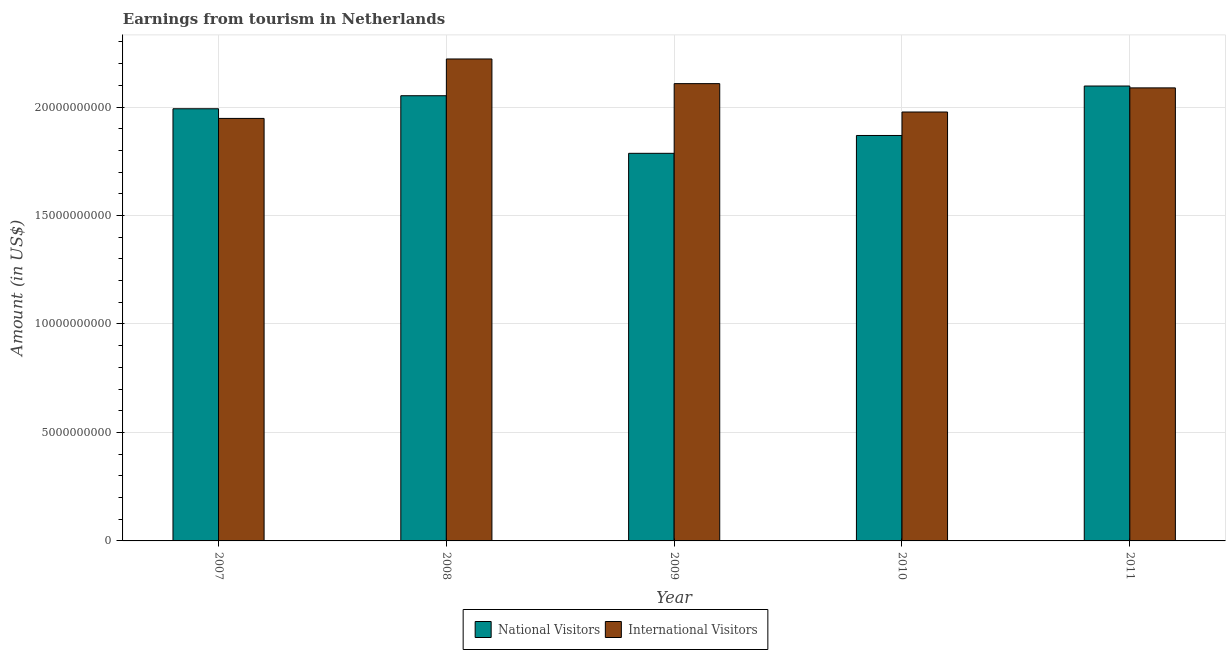How many different coloured bars are there?
Offer a terse response. 2. Are the number of bars on each tick of the X-axis equal?
Provide a short and direct response. Yes. How many bars are there on the 4th tick from the right?
Ensure brevity in your answer.  2. What is the label of the 2nd group of bars from the left?
Keep it short and to the point. 2008. In how many cases, is the number of bars for a given year not equal to the number of legend labels?
Provide a short and direct response. 0. What is the amount earned from national visitors in 2010?
Keep it short and to the point. 1.87e+1. Across all years, what is the maximum amount earned from national visitors?
Your response must be concise. 2.10e+1. Across all years, what is the minimum amount earned from international visitors?
Make the answer very short. 1.95e+1. In which year was the amount earned from international visitors maximum?
Give a very brief answer. 2008. In which year was the amount earned from national visitors minimum?
Keep it short and to the point. 2009. What is the total amount earned from international visitors in the graph?
Your answer should be very brief. 1.03e+11. What is the difference between the amount earned from national visitors in 2007 and that in 2010?
Your response must be concise. 1.23e+09. What is the difference between the amount earned from national visitors in 2009 and the amount earned from international visitors in 2007?
Keep it short and to the point. -2.05e+09. What is the average amount earned from international visitors per year?
Keep it short and to the point. 2.07e+1. In the year 2009, what is the difference between the amount earned from international visitors and amount earned from national visitors?
Provide a short and direct response. 0. What is the ratio of the amount earned from international visitors in 2007 to that in 2011?
Offer a very short reply. 0.93. Is the amount earned from national visitors in 2009 less than that in 2010?
Keep it short and to the point. Yes. Is the difference between the amount earned from national visitors in 2009 and 2011 greater than the difference between the amount earned from international visitors in 2009 and 2011?
Your response must be concise. No. What is the difference between the highest and the second highest amount earned from international visitors?
Provide a succinct answer. 1.14e+09. What is the difference between the highest and the lowest amount earned from international visitors?
Your response must be concise. 2.74e+09. Is the sum of the amount earned from international visitors in 2007 and 2008 greater than the maximum amount earned from national visitors across all years?
Keep it short and to the point. Yes. What does the 2nd bar from the left in 2011 represents?
Provide a succinct answer. International Visitors. What does the 1st bar from the right in 2010 represents?
Ensure brevity in your answer.  International Visitors. What is the difference between two consecutive major ticks on the Y-axis?
Provide a short and direct response. 5.00e+09. Does the graph contain any zero values?
Make the answer very short. No. What is the title of the graph?
Ensure brevity in your answer.  Earnings from tourism in Netherlands. What is the label or title of the Y-axis?
Offer a terse response. Amount (in US$). What is the Amount (in US$) of National Visitors in 2007?
Ensure brevity in your answer.  1.99e+1. What is the Amount (in US$) in International Visitors in 2007?
Provide a succinct answer. 1.95e+1. What is the Amount (in US$) in National Visitors in 2008?
Your response must be concise. 2.05e+1. What is the Amount (in US$) of International Visitors in 2008?
Your response must be concise. 2.22e+1. What is the Amount (in US$) in National Visitors in 2009?
Offer a very short reply. 1.79e+1. What is the Amount (in US$) of International Visitors in 2009?
Your response must be concise. 2.11e+1. What is the Amount (in US$) in National Visitors in 2010?
Your answer should be very brief. 1.87e+1. What is the Amount (in US$) in International Visitors in 2010?
Offer a terse response. 1.98e+1. What is the Amount (in US$) in National Visitors in 2011?
Give a very brief answer. 2.10e+1. What is the Amount (in US$) in International Visitors in 2011?
Keep it short and to the point. 2.09e+1. Across all years, what is the maximum Amount (in US$) in National Visitors?
Provide a succinct answer. 2.10e+1. Across all years, what is the maximum Amount (in US$) in International Visitors?
Make the answer very short. 2.22e+1. Across all years, what is the minimum Amount (in US$) of National Visitors?
Ensure brevity in your answer.  1.79e+1. Across all years, what is the minimum Amount (in US$) in International Visitors?
Give a very brief answer. 1.95e+1. What is the total Amount (in US$) in National Visitors in the graph?
Provide a short and direct response. 9.80e+1. What is the total Amount (in US$) of International Visitors in the graph?
Your answer should be compact. 1.03e+11. What is the difference between the Amount (in US$) of National Visitors in 2007 and that in 2008?
Make the answer very short. -6.01e+08. What is the difference between the Amount (in US$) in International Visitors in 2007 and that in 2008?
Make the answer very short. -2.74e+09. What is the difference between the Amount (in US$) in National Visitors in 2007 and that in 2009?
Give a very brief answer. 2.05e+09. What is the difference between the Amount (in US$) in International Visitors in 2007 and that in 2009?
Provide a short and direct response. -1.60e+09. What is the difference between the Amount (in US$) of National Visitors in 2007 and that in 2010?
Your answer should be very brief. 1.23e+09. What is the difference between the Amount (in US$) of International Visitors in 2007 and that in 2010?
Offer a very short reply. -2.95e+08. What is the difference between the Amount (in US$) in National Visitors in 2007 and that in 2011?
Ensure brevity in your answer.  -1.05e+09. What is the difference between the Amount (in US$) in International Visitors in 2007 and that in 2011?
Make the answer very short. -1.41e+09. What is the difference between the Amount (in US$) of National Visitors in 2008 and that in 2009?
Your answer should be very brief. 2.66e+09. What is the difference between the Amount (in US$) of International Visitors in 2008 and that in 2009?
Give a very brief answer. 1.14e+09. What is the difference between the Amount (in US$) of National Visitors in 2008 and that in 2010?
Make the answer very short. 1.83e+09. What is the difference between the Amount (in US$) of International Visitors in 2008 and that in 2010?
Your answer should be very brief. 2.44e+09. What is the difference between the Amount (in US$) in National Visitors in 2008 and that in 2011?
Offer a very short reply. -4.47e+08. What is the difference between the Amount (in US$) in International Visitors in 2008 and that in 2011?
Ensure brevity in your answer.  1.33e+09. What is the difference between the Amount (in US$) in National Visitors in 2009 and that in 2010?
Your answer should be compact. -8.22e+08. What is the difference between the Amount (in US$) in International Visitors in 2009 and that in 2010?
Keep it short and to the point. 1.31e+09. What is the difference between the Amount (in US$) of National Visitors in 2009 and that in 2011?
Ensure brevity in your answer.  -3.10e+09. What is the difference between the Amount (in US$) of International Visitors in 2009 and that in 2011?
Keep it short and to the point. 1.96e+08. What is the difference between the Amount (in US$) of National Visitors in 2010 and that in 2011?
Provide a short and direct response. -2.28e+09. What is the difference between the Amount (in US$) of International Visitors in 2010 and that in 2011?
Ensure brevity in your answer.  -1.11e+09. What is the difference between the Amount (in US$) of National Visitors in 2007 and the Amount (in US$) of International Visitors in 2008?
Offer a very short reply. -2.30e+09. What is the difference between the Amount (in US$) of National Visitors in 2007 and the Amount (in US$) of International Visitors in 2009?
Offer a terse response. -1.16e+09. What is the difference between the Amount (in US$) in National Visitors in 2007 and the Amount (in US$) in International Visitors in 2010?
Give a very brief answer. 1.50e+08. What is the difference between the Amount (in US$) in National Visitors in 2007 and the Amount (in US$) in International Visitors in 2011?
Offer a very short reply. -9.62e+08. What is the difference between the Amount (in US$) of National Visitors in 2008 and the Amount (in US$) of International Visitors in 2009?
Provide a short and direct response. -5.57e+08. What is the difference between the Amount (in US$) of National Visitors in 2008 and the Amount (in US$) of International Visitors in 2010?
Provide a succinct answer. 7.51e+08. What is the difference between the Amount (in US$) of National Visitors in 2008 and the Amount (in US$) of International Visitors in 2011?
Keep it short and to the point. -3.61e+08. What is the difference between the Amount (in US$) in National Visitors in 2009 and the Amount (in US$) in International Visitors in 2010?
Provide a succinct answer. -1.90e+09. What is the difference between the Amount (in US$) in National Visitors in 2009 and the Amount (in US$) in International Visitors in 2011?
Provide a succinct answer. -3.02e+09. What is the difference between the Amount (in US$) in National Visitors in 2010 and the Amount (in US$) in International Visitors in 2011?
Your answer should be compact. -2.19e+09. What is the average Amount (in US$) of National Visitors per year?
Offer a terse response. 1.96e+1. What is the average Amount (in US$) in International Visitors per year?
Offer a very short reply. 2.07e+1. In the year 2007, what is the difference between the Amount (in US$) in National Visitors and Amount (in US$) in International Visitors?
Ensure brevity in your answer.  4.45e+08. In the year 2008, what is the difference between the Amount (in US$) in National Visitors and Amount (in US$) in International Visitors?
Offer a very short reply. -1.69e+09. In the year 2009, what is the difference between the Amount (in US$) in National Visitors and Amount (in US$) in International Visitors?
Make the answer very short. -3.21e+09. In the year 2010, what is the difference between the Amount (in US$) of National Visitors and Amount (in US$) of International Visitors?
Your response must be concise. -1.08e+09. In the year 2011, what is the difference between the Amount (in US$) of National Visitors and Amount (in US$) of International Visitors?
Make the answer very short. 8.60e+07. What is the ratio of the Amount (in US$) in National Visitors in 2007 to that in 2008?
Offer a terse response. 0.97. What is the ratio of the Amount (in US$) in International Visitors in 2007 to that in 2008?
Make the answer very short. 0.88. What is the ratio of the Amount (in US$) in National Visitors in 2007 to that in 2009?
Provide a short and direct response. 1.11. What is the ratio of the Amount (in US$) of International Visitors in 2007 to that in 2009?
Make the answer very short. 0.92. What is the ratio of the Amount (in US$) of National Visitors in 2007 to that in 2010?
Keep it short and to the point. 1.07. What is the ratio of the Amount (in US$) in International Visitors in 2007 to that in 2010?
Provide a short and direct response. 0.99. What is the ratio of the Amount (in US$) of International Visitors in 2007 to that in 2011?
Provide a short and direct response. 0.93. What is the ratio of the Amount (in US$) of National Visitors in 2008 to that in 2009?
Your response must be concise. 1.15. What is the ratio of the Amount (in US$) of International Visitors in 2008 to that in 2009?
Offer a terse response. 1.05. What is the ratio of the Amount (in US$) in National Visitors in 2008 to that in 2010?
Give a very brief answer. 1.1. What is the ratio of the Amount (in US$) of International Visitors in 2008 to that in 2010?
Provide a short and direct response. 1.12. What is the ratio of the Amount (in US$) in National Visitors in 2008 to that in 2011?
Offer a very short reply. 0.98. What is the ratio of the Amount (in US$) of International Visitors in 2008 to that in 2011?
Ensure brevity in your answer.  1.06. What is the ratio of the Amount (in US$) of National Visitors in 2009 to that in 2010?
Provide a short and direct response. 0.96. What is the ratio of the Amount (in US$) of International Visitors in 2009 to that in 2010?
Your answer should be very brief. 1.07. What is the ratio of the Amount (in US$) of National Visitors in 2009 to that in 2011?
Your response must be concise. 0.85. What is the ratio of the Amount (in US$) in International Visitors in 2009 to that in 2011?
Offer a terse response. 1.01. What is the ratio of the Amount (in US$) of National Visitors in 2010 to that in 2011?
Offer a very short reply. 0.89. What is the ratio of the Amount (in US$) of International Visitors in 2010 to that in 2011?
Your response must be concise. 0.95. What is the difference between the highest and the second highest Amount (in US$) in National Visitors?
Your answer should be compact. 4.47e+08. What is the difference between the highest and the second highest Amount (in US$) in International Visitors?
Ensure brevity in your answer.  1.14e+09. What is the difference between the highest and the lowest Amount (in US$) of National Visitors?
Ensure brevity in your answer.  3.10e+09. What is the difference between the highest and the lowest Amount (in US$) in International Visitors?
Offer a terse response. 2.74e+09. 